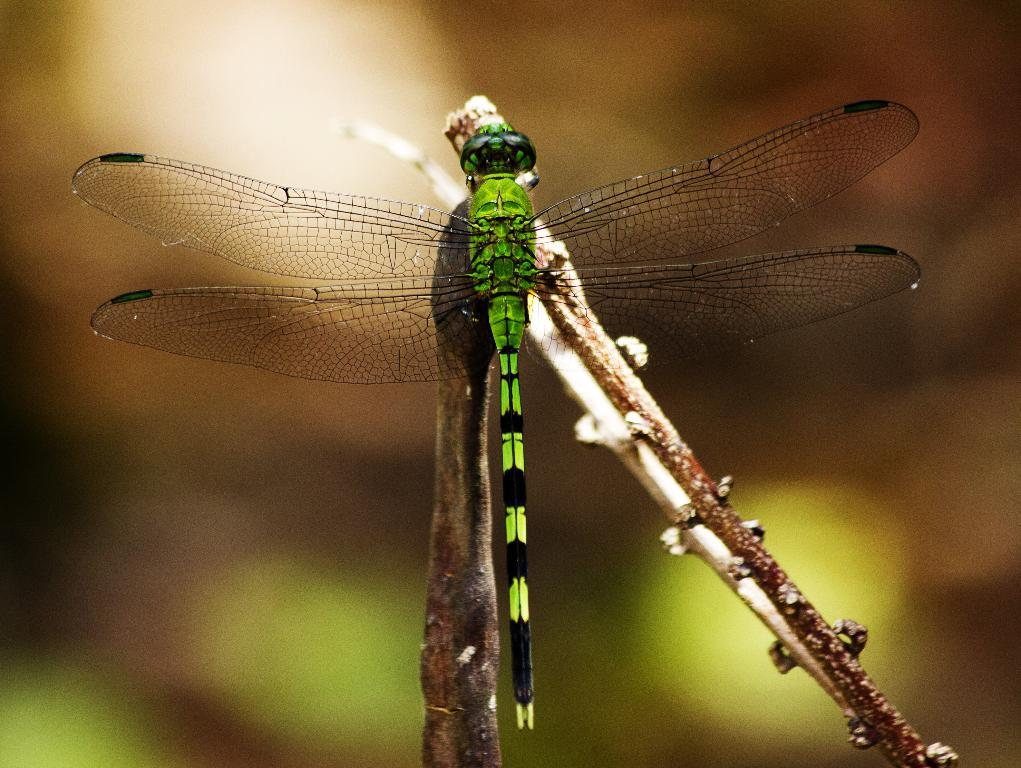What is the main subject of the image? The main subject of the image is a dragonfly. Where is the dragonfly located in the image? The dragonfly is in the middle of the image. What can be observed about the background of the image? The background of the image is blurry. What type of game is being played in the image? There is no game present in the image; it features a dragonfly. What is the dragonfly writing in the notebook in the image? There is no notebook present in the image, and the dragonfly is not depicted as performing any actions that would involve writing. 